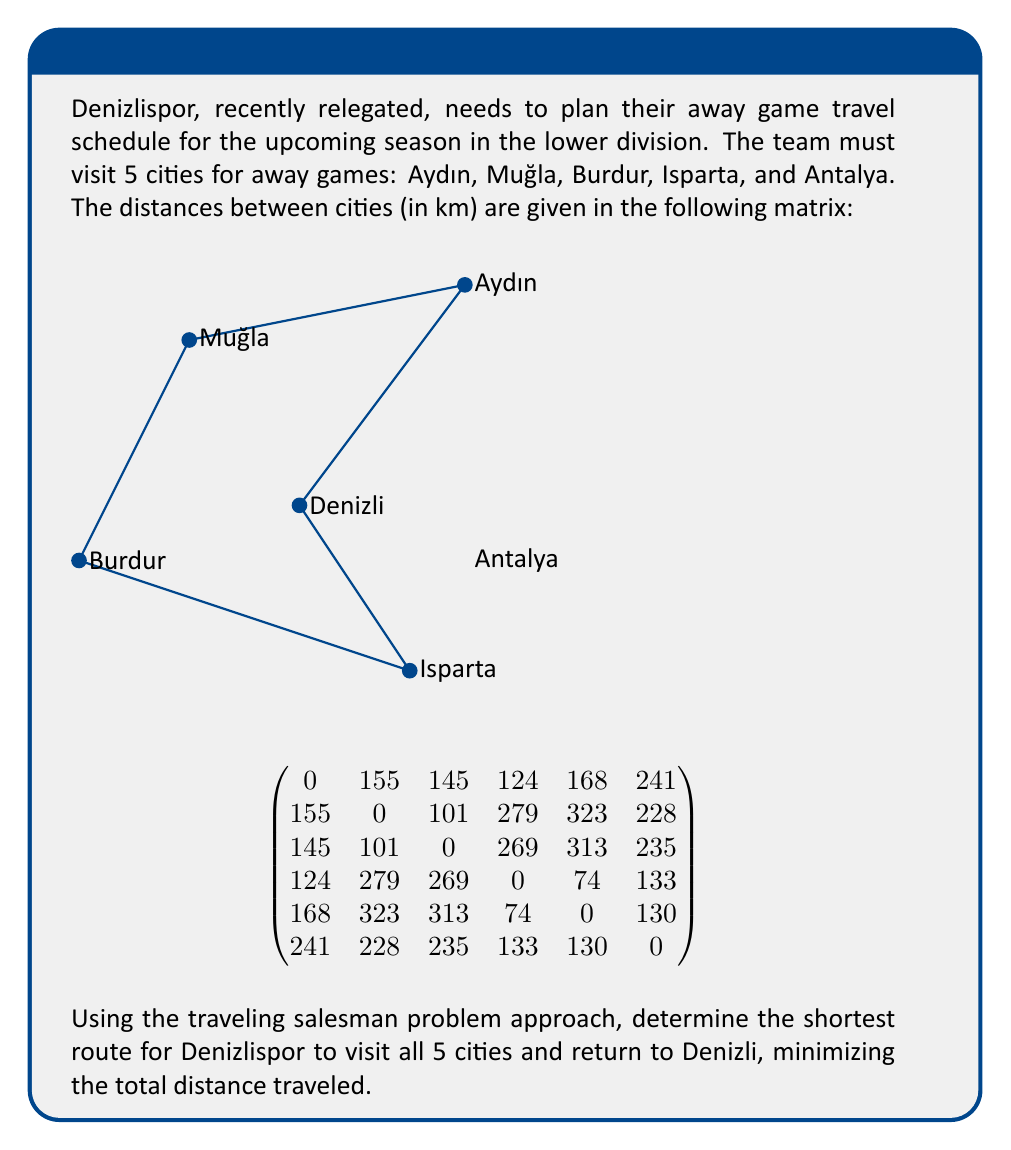Teach me how to tackle this problem. To solve this traveling salesman problem for Denizlispor's away games, we'll use the nearest neighbor heuristic algorithm. While this method doesn't guarantee the optimal solution, it provides a good approximation and is computationally efficient.

Step 1: Start from Denizli (home city).

Step 2: Find the nearest unvisited city:
- Denizli to Burdur: 124 km (shortest)
- Move to Burdur

Step 3: From Burdur, find the nearest unvisited city:
- Burdur to Isparta: 74 km (shortest)
- Move to Isparta

Step 4: From Isparta, find the nearest unvisited city:
- Isparta to Antalya: 130 km (shortest)
- Move to Antalya

Step 5: From Antalya, find the nearest unvisited city:
- Antalya to Muğla: 235 km (shortest)
- Move to Muğla

Step 6: From Muğla, visit the last unvisited city:
- Muğla to Aydın: 101 km
- Move to Aydın

Step 7: Return to Denizli from Aydın:
- Aydın to Denizli: 155 km

The total route is:
Denizli → Burdur → Isparta → Antalya → Muğla → Aydın → Denizli

Calculate total distance:
$124 + 74 + 130 + 235 + 101 + 155 = 819$ km

Therefore, the shortest route for Denizlispor to visit all 5 cities and return to Denizli is approximately 819 km.
Answer: Denizli → Burdur → Isparta → Antalya → Muğla → Aydın → Denizli, 819 km 